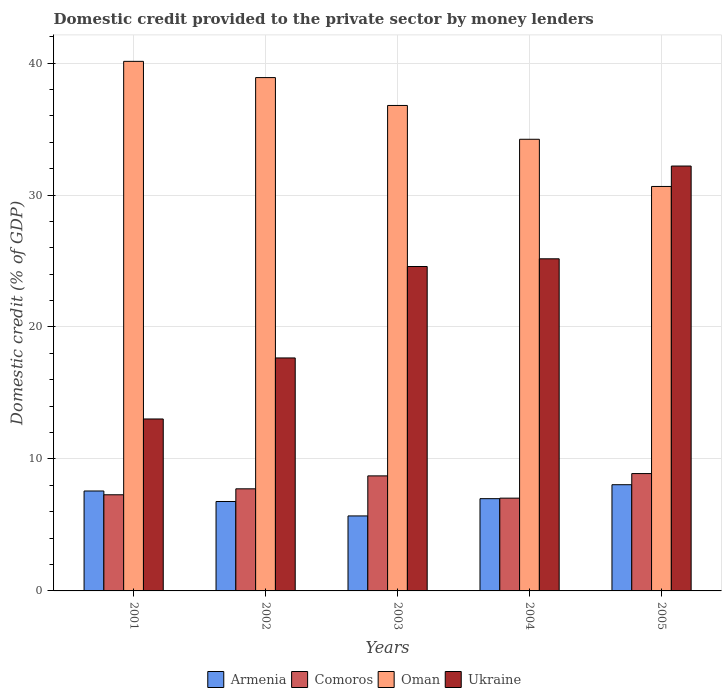How many groups of bars are there?
Your response must be concise. 5. Are the number of bars on each tick of the X-axis equal?
Ensure brevity in your answer.  Yes. In how many cases, is the number of bars for a given year not equal to the number of legend labels?
Offer a terse response. 0. What is the domestic credit provided to the private sector by money lenders in Armenia in 2005?
Provide a succinct answer. 8.05. Across all years, what is the maximum domestic credit provided to the private sector by money lenders in Ukraine?
Make the answer very short. 32.2. Across all years, what is the minimum domestic credit provided to the private sector by money lenders in Armenia?
Ensure brevity in your answer.  5.68. In which year was the domestic credit provided to the private sector by money lenders in Ukraine minimum?
Your response must be concise. 2001. What is the total domestic credit provided to the private sector by money lenders in Armenia in the graph?
Your answer should be compact. 35.07. What is the difference between the domestic credit provided to the private sector by money lenders in Comoros in 2001 and that in 2002?
Provide a short and direct response. -0.45. What is the difference between the domestic credit provided to the private sector by money lenders in Oman in 2001 and the domestic credit provided to the private sector by money lenders in Comoros in 2002?
Provide a short and direct response. 32.39. What is the average domestic credit provided to the private sector by money lenders in Comoros per year?
Give a very brief answer. 7.93. In the year 2001, what is the difference between the domestic credit provided to the private sector by money lenders in Oman and domestic credit provided to the private sector by money lenders in Ukraine?
Offer a very short reply. 27.1. What is the ratio of the domestic credit provided to the private sector by money lenders in Ukraine in 2001 to that in 2002?
Provide a short and direct response. 0.74. Is the domestic credit provided to the private sector by money lenders in Oman in 2001 less than that in 2002?
Your answer should be very brief. No. What is the difference between the highest and the second highest domestic credit provided to the private sector by money lenders in Armenia?
Provide a short and direct response. 0.47. What is the difference between the highest and the lowest domestic credit provided to the private sector by money lenders in Comoros?
Your answer should be very brief. 1.86. Is the sum of the domestic credit provided to the private sector by money lenders in Oman in 2001 and 2002 greater than the maximum domestic credit provided to the private sector by money lenders in Armenia across all years?
Offer a terse response. Yes. Is it the case that in every year, the sum of the domestic credit provided to the private sector by money lenders in Ukraine and domestic credit provided to the private sector by money lenders in Armenia is greater than the sum of domestic credit provided to the private sector by money lenders in Comoros and domestic credit provided to the private sector by money lenders in Oman?
Your answer should be very brief. No. What does the 3rd bar from the left in 2002 represents?
Make the answer very short. Oman. What does the 1st bar from the right in 2003 represents?
Provide a succinct answer. Ukraine. Is it the case that in every year, the sum of the domestic credit provided to the private sector by money lenders in Oman and domestic credit provided to the private sector by money lenders in Armenia is greater than the domestic credit provided to the private sector by money lenders in Ukraine?
Offer a terse response. Yes. How many bars are there?
Offer a terse response. 20. Are all the bars in the graph horizontal?
Give a very brief answer. No. How many years are there in the graph?
Give a very brief answer. 5. Are the values on the major ticks of Y-axis written in scientific E-notation?
Ensure brevity in your answer.  No. Does the graph contain grids?
Your answer should be very brief. Yes. How are the legend labels stacked?
Your answer should be compact. Horizontal. What is the title of the graph?
Provide a succinct answer. Domestic credit provided to the private sector by money lenders. What is the label or title of the Y-axis?
Offer a very short reply. Domestic credit (% of GDP). What is the Domestic credit (% of GDP) in Armenia in 2001?
Provide a succinct answer. 7.57. What is the Domestic credit (% of GDP) in Comoros in 2001?
Your response must be concise. 7.29. What is the Domestic credit (% of GDP) of Oman in 2001?
Make the answer very short. 40.13. What is the Domestic credit (% of GDP) of Ukraine in 2001?
Offer a terse response. 13.03. What is the Domestic credit (% of GDP) of Armenia in 2002?
Offer a terse response. 6.78. What is the Domestic credit (% of GDP) of Comoros in 2002?
Provide a succinct answer. 7.74. What is the Domestic credit (% of GDP) of Oman in 2002?
Provide a succinct answer. 38.9. What is the Domestic credit (% of GDP) of Ukraine in 2002?
Your answer should be very brief. 17.65. What is the Domestic credit (% of GDP) of Armenia in 2003?
Offer a very short reply. 5.68. What is the Domestic credit (% of GDP) of Comoros in 2003?
Offer a terse response. 8.72. What is the Domestic credit (% of GDP) of Oman in 2003?
Keep it short and to the point. 36.79. What is the Domestic credit (% of GDP) of Ukraine in 2003?
Make the answer very short. 24.58. What is the Domestic credit (% of GDP) in Armenia in 2004?
Give a very brief answer. 6.99. What is the Domestic credit (% of GDP) in Comoros in 2004?
Provide a succinct answer. 7.03. What is the Domestic credit (% of GDP) in Oman in 2004?
Provide a succinct answer. 34.23. What is the Domestic credit (% of GDP) of Ukraine in 2004?
Ensure brevity in your answer.  25.17. What is the Domestic credit (% of GDP) in Armenia in 2005?
Provide a short and direct response. 8.05. What is the Domestic credit (% of GDP) of Comoros in 2005?
Provide a short and direct response. 8.89. What is the Domestic credit (% of GDP) in Oman in 2005?
Give a very brief answer. 30.65. What is the Domestic credit (% of GDP) of Ukraine in 2005?
Provide a short and direct response. 32.2. Across all years, what is the maximum Domestic credit (% of GDP) of Armenia?
Offer a very short reply. 8.05. Across all years, what is the maximum Domestic credit (% of GDP) of Comoros?
Your answer should be very brief. 8.89. Across all years, what is the maximum Domestic credit (% of GDP) in Oman?
Ensure brevity in your answer.  40.13. Across all years, what is the maximum Domestic credit (% of GDP) in Ukraine?
Your answer should be very brief. 32.2. Across all years, what is the minimum Domestic credit (% of GDP) in Armenia?
Provide a succinct answer. 5.68. Across all years, what is the minimum Domestic credit (% of GDP) in Comoros?
Make the answer very short. 7.03. Across all years, what is the minimum Domestic credit (% of GDP) of Oman?
Give a very brief answer. 30.65. Across all years, what is the minimum Domestic credit (% of GDP) of Ukraine?
Your answer should be very brief. 13.03. What is the total Domestic credit (% of GDP) of Armenia in the graph?
Offer a very short reply. 35.07. What is the total Domestic credit (% of GDP) in Comoros in the graph?
Offer a terse response. 39.66. What is the total Domestic credit (% of GDP) in Oman in the graph?
Make the answer very short. 180.69. What is the total Domestic credit (% of GDP) in Ukraine in the graph?
Your answer should be compact. 112.63. What is the difference between the Domestic credit (% of GDP) of Armenia in 2001 and that in 2002?
Provide a short and direct response. 0.8. What is the difference between the Domestic credit (% of GDP) in Comoros in 2001 and that in 2002?
Your answer should be compact. -0.45. What is the difference between the Domestic credit (% of GDP) in Oman in 2001 and that in 2002?
Offer a terse response. 1.23. What is the difference between the Domestic credit (% of GDP) in Ukraine in 2001 and that in 2002?
Make the answer very short. -4.63. What is the difference between the Domestic credit (% of GDP) in Armenia in 2001 and that in 2003?
Give a very brief answer. 1.89. What is the difference between the Domestic credit (% of GDP) of Comoros in 2001 and that in 2003?
Ensure brevity in your answer.  -1.43. What is the difference between the Domestic credit (% of GDP) in Oman in 2001 and that in 2003?
Keep it short and to the point. 3.34. What is the difference between the Domestic credit (% of GDP) of Ukraine in 2001 and that in 2003?
Keep it short and to the point. -11.55. What is the difference between the Domestic credit (% of GDP) in Armenia in 2001 and that in 2004?
Keep it short and to the point. 0.58. What is the difference between the Domestic credit (% of GDP) of Comoros in 2001 and that in 2004?
Make the answer very short. 0.26. What is the difference between the Domestic credit (% of GDP) of Oman in 2001 and that in 2004?
Provide a short and direct response. 5.9. What is the difference between the Domestic credit (% of GDP) in Ukraine in 2001 and that in 2004?
Your answer should be very brief. -12.14. What is the difference between the Domestic credit (% of GDP) of Armenia in 2001 and that in 2005?
Offer a very short reply. -0.47. What is the difference between the Domestic credit (% of GDP) of Comoros in 2001 and that in 2005?
Offer a terse response. -1.61. What is the difference between the Domestic credit (% of GDP) in Oman in 2001 and that in 2005?
Your answer should be compact. 9.48. What is the difference between the Domestic credit (% of GDP) in Ukraine in 2001 and that in 2005?
Your answer should be compact. -19.17. What is the difference between the Domestic credit (% of GDP) in Armenia in 2002 and that in 2003?
Keep it short and to the point. 1.09. What is the difference between the Domestic credit (% of GDP) in Comoros in 2002 and that in 2003?
Give a very brief answer. -0.98. What is the difference between the Domestic credit (% of GDP) of Oman in 2002 and that in 2003?
Keep it short and to the point. 2.11. What is the difference between the Domestic credit (% of GDP) in Ukraine in 2002 and that in 2003?
Give a very brief answer. -6.93. What is the difference between the Domestic credit (% of GDP) of Armenia in 2002 and that in 2004?
Offer a terse response. -0.21. What is the difference between the Domestic credit (% of GDP) in Comoros in 2002 and that in 2004?
Offer a very short reply. 0.71. What is the difference between the Domestic credit (% of GDP) of Oman in 2002 and that in 2004?
Offer a very short reply. 4.67. What is the difference between the Domestic credit (% of GDP) in Ukraine in 2002 and that in 2004?
Your answer should be very brief. -7.51. What is the difference between the Domestic credit (% of GDP) of Armenia in 2002 and that in 2005?
Your answer should be very brief. -1.27. What is the difference between the Domestic credit (% of GDP) of Comoros in 2002 and that in 2005?
Give a very brief answer. -1.16. What is the difference between the Domestic credit (% of GDP) in Oman in 2002 and that in 2005?
Offer a very short reply. 8.25. What is the difference between the Domestic credit (% of GDP) in Ukraine in 2002 and that in 2005?
Your answer should be compact. -14.54. What is the difference between the Domestic credit (% of GDP) of Armenia in 2003 and that in 2004?
Give a very brief answer. -1.31. What is the difference between the Domestic credit (% of GDP) of Comoros in 2003 and that in 2004?
Your answer should be compact. 1.69. What is the difference between the Domestic credit (% of GDP) of Oman in 2003 and that in 2004?
Your answer should be compact. 2.56. What is the difference between the Domestic credit (% of GDP) in Ukraine in 2003 and that in 2004?
Your answer should be compact. -0.58. What is the difference between the Domestic credit (% of GDP) in Armenia in 2003 and that in 2005?
Give a very brief answer. -2.37. What is the difference between the Domestic credit (% of GDP) of Comoros in 2003 and that in 2005?
Ensure brevity in your answer.  -0.18. What is the difference between the Domestic credit (% of GDP) in Oman in 2003 and that in 2005?
Offer a terse response. 6.14. What is the difference between the Domestic credit (% of GDP) of Ukraine in 2003 and that in 2005?
Ensure brevity in your answer.  -7.61. What is the difference between the Domestic credit (% of GDP) of Armenia in 2004 and that in 2005?
Ensure brevity in your answer.  -1.06. What is the difference between the Domestic credit (% of GDP) of Comoros in 2004 and that in 2005?
Make the answer very short. -1.86. What is the difference between the Domestic credit (% of GDP) of Oman in 2004 and that in 2005?
Offer a terse response. 3.58. What is the difference between the Domestic credit (% of GDP) in Ukraine in 2004 and that in 2005?
Ensure brevity in your answer.  -7.03. What is the difference between the Domestic credit (% of GDP) of Armenia in 2001 and the Domestic credit (% of GDP) of Comoros in 2002?
Ensure brevity in your answer.  -0.16. What is the difference between the Domestic credit (% of GDP) of Armenia in 2001 and the Domestic credit (% of GDP) of Oman in 2002?
Offer a very short reply. -31.33. What is the difference between the Domestic credit (% of GDP) of Armenia in 2001 and the Domestic credit (% of GDP) of Ukraine in 2002?
Ensure brevity in your answer.  -10.08. What is the difference between the Domestic credit (% of GDP) in Comoros in 2001 and the Domestic credit (% of GDP) in Oman in 2002?
Your answer should be compact. -31.61. What is the difference between the Domestic credit (% of GDP) in Comoros in 2001 and the Domestic credit (% of GDP) in Ukraine in 2002?
Offer a terse response. -10.37. What is the difference between the Domestic credit (% of GDP) in Oman in 2001 and the Domestic credit (% of GDP) in Ukraine in 2002?
Offer a terse response. 22.48. What is the difference between the Domestic credit (% of GDP) of Armenia in 2001 and the Domestic credit (% of GDP) of Comoros in 2003?
Provide a short and direct response. -1.14. What is the difference between the Domestic credit (% of GDP) in Armenia in 2001 and the Domestic credit (% of GDP) in Oman in 2003?
Give a very brief answer. -29.21. What is the difference between the Domestic credit (% of GDP) in Armenia in 2001 and the Domestic credit (% of GDP) in Ukraine in 2003?
Keep it short and to the point. -17.01. What is the difference between the Domestic credit (% of GDP) of Comoros in 2001 and the Domestic credit (% of GDP) of Oman in 2003?
Keep it short and to the point. -29.5. What is the difference between the Domestic credit (% of GDP) in Comoros in 2001 and the Domestic credit (% of GDP) in Ukraine in 2003?
Offer a terse response. -17.3. What is the difference between the Domestic credit (% of GDP) in Oman in 2001 and the Domestic credit (% of GDP) in Ukraine in 2003?
Give a very brief answer. 15.55. What is the difference between the Domestic credit (% of GDP) of Armenia in 2001 and the Domestic credit (% of GDP) of Comoros in 2004?
Make the answer very short. 0.54. What is the difference between the Domestic credit (% of GDP) of Armenia in 2001 and the Domestic credit (% of GDP) of Oman in 2004?
Offer a very short reply. -26.65. What is the difference between the Domestic credit (% of GDP) of Armenia in 2001 and the Domestic credit (% of GDP) of Ukraine in 2004?
Ensure brevity in your answer.  -17.59. What is the difference between the Domestic credit (% of GDP) of Comoros in 2001 and the Domestic credit (% of GDP) of Oman in 2004?
Offer a terse response. -26.94. What is the difference between the Domestic credit (% of GDP) of Comoros in 2001 and the Domestic credit (% of GDP) of Ukraine in 2004?
Make the answer very short. -17.88. What is the difference between the Domestic credit (% of GDP) of Oman in 2001 and the Domestic credit (% of GDP) of Ukraine in 2004?
Offer a terse response. 14.96. What is the difference between the Domestic credit (% of GDP) of Armenia in 2001 and the Domestic credit (% of GDP) of Comoros in 2005?
Give a very brief answer. -1.32. What is the difference between the Domestic credit (% of GDP) in Armenia in 2001 and the Domestic credit (% of GDP) in Oman in 2005?
Offer a terse response. -23.08. What is the difference between the Domestic credit (% of GDP) in Armenia in 2001 and the Domestic credit (% of GDP) in Ukraine in 2005?
Your response must be concise. -24.62. What is the difference between the Domestic credit (% of GDP) of Comoros in 2001 and the Domestic credit (% of GDP) of Oman in 2005?
Provide a short and direct response. -23.36. What is the difference between the Domestic credit (% of GDP) in Comoros in 2001 and the Domestic credit (% of GDP) in Ukraine in 2005?
Provide a short and direct response. -24.91. What is the difference between the Domestic credit (% of GDP) in Oman in 2001 and the Domestic credit (% of GDP) in Ukraine in 2005?
Your answer should be very brief. 7.93. What is the difference between the Domestic credit (% of GDP) in Armenia in 2002 and the Domestic credit (% of GDP) in Comoros in 2003?
Your response must be concise. -1.94. What is the difference between the Domestic credit (% of GDP) in Armenia in 2002 and the Domestic credit (% of GDP) in Oman in 2003?
Offer a terse response. -30.01. What is the difference between the Domestic credit (% of GDP) in Armenia in 2002 and the Domestic credit (% of GDP) in Ukraine in 2003?
Keep it short and to the point. -17.81. What is the difference between the Domestic credit (% of GDP) in Comoros in 2002 and the Domestic credit (% of GDP) in Oman in 2003?
Offer a very short reply. -29.05. What is the difference between the Domestic credit (% of GDP) of Comoros in 2002 and the Domestic credit (% of GDP) of Ukraine in 2003?
Offer a very short reply. -16.85. What is the difference between the Domestic credit (% of GDP) in Oman in 2002 and the Domestic credit (% of GDP) in Ukraine in 2003?
Your response must be concise. 14.32. What is the difference between the Domestic credit (% of GDP) in Armenia in 2002 and the Domestic credit (% of GDP) in Comoros in 2004?
Ensure brevity in your answer.  -0.25. What is the difference between the Domestic credit (% of GDP) in Armenia in 2002 and the Domestic credit (% of GDP) in Oman in 2004?
Ensure brevity in your answer.  -27.45. What is the difference between the Domestic credit (% of GDP) of Armenia in 2002 and the Domestic credit (% of GDP) of Ukraine in 2004?
Your response must be concise. -18.39. What is the difference between the Domestic credit (% of GDP) of Comoros in 2002 and the Domestic credit (% of GDP) of Oman in 2004?
Your response must be concise. -26.49. What is the difference between the Domestic credit (% of GDP) of Comoros in 2002 and the Domestic credit (% of GDP) of Ukraine in 2004?
Provide a succinct answer. -17.43. What is the difference between the Domestic credit (% of GDP) of Oman in 2002 and the Domestic credit (% of GDP) of Ukraine in 2004?
Offer a very short reply. 13.73. What is the difference between the Domestic credit (% of GDP) of Armenia in 2002 and the Domestic credit (% of GDP) of Comoros in 2005?
Offer a very short reply. -2.12. What is the difference between the Domestic credit (% of GDP) in Armenia in 2002 and the Domestic credit (% of GDP) in Oman in 2005?
Your response must be concise. -23.87. What is the difference between the Domestic credit (% of GDP) in Armenia in 2002 and the Domestic credit (% of GDP) in Ukraine in 2005?
Your answer should be compact. -25.42. What is the difference between the Domestic credit (% of GDP) in Comoros in 2002 and the Domestic credit (% of GDP) in Oman in 2005?
Your answer should be compact. -22.91. What is the difference between the Domestic credit (% of GDP) in Comoros in 2002 and the Domestic credit (% of GDP) in Ukraine in 2005?
Ensure brevity in your answer.  -24.46. What is the difference between the Domestic credit (% of GDP) in Oman in 2002 and the Domestic credit (% of GDP) in Ukraine in 2005?
Provide a succinct answer. 6.7. What is the difference between the Domestic credit (% of GDP) of Armenia in 2003 and the Domestic credit (% of GDP) of Comoros in 2004?
Your response must be concise. -1.35. What is the difference between the Domestic credit (% of GDP) in Armenia in 2003 and the Domestic credit (% of GDP) in Oman in 2004?
Keep it short and to the point. -28.54. What is the difference between the Domestic credit (% of GDP) of Armenia in 2003 and the Domestic credit (% of GDP) of Ukraine in 2004?
Make the answer very short. -19.48. What is the difference between the Domestic credit (% of GDP) of Comoros in 2003 and the Domestic credit (% of GDP) of Oman in 2004?
Provide a short and direct response. -25.51. What is the difference between the Domestic credit (% of GDP) in Comoros in 2003 and the Domestic credit (% of GDP) in Ukraine in 2004?
Give a very brief answer. -16.45. What is the difference between the Domestic credit (% of GDP) of Oman in 2003 and the Domestic credit (% of GDP) of Ukraine in 2004?
Keep it short and to the point. 11.62. What is the difference between the Domestic credit (% of GDP) in Armenia in 2003 and the Domestic credit (% of GDP) in Comoros in 2005?
Make the answer very short. -3.21. What is the difference between the Domestic credit (% of GDP) of Armenia in 2003 and the Domestic credit (% of GDP) of Oman in 2005?
Provide a succinct answer. -24.97. What is the difference between the Domestic credit (% of GDP) in Armenia in 2003 and the Domestic credit (% of GDP) in Ukraine in 2005?
Offer a terse response. -26.51. What is the difference between the Domestic credit (% of GDP) in Comoros in 2003 and the Domestic credit (% of GDP) in Oman in 2005?
Your response must be concise. -21.93. What is the difference between the Domestic credit (% of GDP) of Comoros in 2003 and the Domestic credit (% of GDP) of Ukraine in 2005?
Offer a very short reply. -23.48. What is the difference between the Domestic credit (% of GDP) of Oman in 2003 and the Domestic credit (% of GDP) of Ukraine in 2005?
Provide a succinct answer. 4.59. What is the difference between the Domestic credit (% of GDP) in Armenia in 2004 and the Domestic credit (% of GDP) in Comoros in 2005?
Your answer should be very brief. -1.9. What is the difference between the Domestic credit (% of GDP) of Armenia in 2004 and the Domestic credit (% of GDP) of Oman in 2005?
Give a very brief answer. -23.66. What is the difference between the Domestic credit (% of GDP) in Armenia in 2004 and the Domestic credit (% of GDP) in Ukraine in 2005?
Provide a short and direct response. -25.21. What is the difference between the Domestic credit (% of GDP) in Comoros in 2004 and the Domestic credit (% of GDP) in Oman in 2005?
Offer a terse response. -23.62. What is the difference between the Domestic credit (% of GDP) of Comoros in 2004 and the Domestic credit (% of GDP) of Ukraine in 2005?
Your answer should be very brief. -25.17. What is the difference between the Domestic credit (% of GDP) of Oman in 2004 and the Domestic credit (% of GDP) of Ukraine in 2005?
Provide a short and direct response. 2.03. What is the average Domestic credit (% of GDP) in Armenia per year?
Offer a very short reply. 7.01. What is the average Domestic credit (% of GDP) in Comoros per year?
Offer a very short reply. 7.93. What is the average Domestic credit (% of GDP) of Oman per year?
Ensure brevity in your answer.  36.14. What is the average Domestic credit (% of GDP) in Ukraine per year?
Offer a terse response. 22.53. In the year 2001, what is the difference between the Domestic credit (% of GDP) of Armenia and Domestic credit (% of GDP) of Comoros?
Keep it short and to the point. 0.29. In the year 2001, what is the difference between the Domestic credit (% of GDP) of Armenia and Domestic credit (% of GDP) of Oman?
Provide a short and direct response. -32.56. In the year 2001, what is the difference between the Domestic credit (% of GDP) in Armenia and Domestic credit (% of GDP) in Ukraine?
Give a very brief answer. -5.46. In the year 2001, what is the difference between the Domestic credit (% of GDP) of Comoros and Domestic credit (% of GDP) of Oman?
Offer a very short reply. -32.84. In the year 2001, what is the difference between the Domestic credit (% of GDP) in Comoros and Domestic credit (% of GDP) in Ukraine?
Offer a terse response. -5.74. In the year 2001, what is the difference between the Domestic credit (% of GDP) of Oman and Domestic credit (% of GDP) of Ukraine?
Ensure brevity in your answer.  27.1. In the year 2002, what is the difference between the Domestic credit (% of GDP) in Armenia and Domestic credit (% of GDP) in Comoros?
Provide a short and direct response. -0.96. In the year 2002, what is the difference between the Domestic credit (% of GDP) in Armenia and Domestic credit (% of GDP) in Oman?
Give a very brief answer. -32.12. In the year 2002, what is the difference between the Domestic credit (% of GDP) in Armenia and Domestic credit (% of GDP) in Ukraine?
Make the answer very short. -10.88. In the year 2002, what is the difference between the Domestic credit (% of GDP) in Comoros and Domestic credit (% of GDP) in Oman?
Your answer should be very brief. -31.16. In the year 2002, what is the difference between the Domestic credit (% of GDP) of Comoros and Domestic credit (% of GDP) of Ukraine?
Ensure brevity in your answer.  -9.92. In the year 2002, what is the difference between the Domestic credit (% of GDP) in Oman and Domestic credit (% of GDP) in Ukraine?
Your response must be concise. 21.24. In the year 2003, what is the difference between the Domestic credit (% of GDP) in Armenia and Domestic credit (% of GDP) in Comoros?
Ensure brevity in your answer.  -3.04. In the year 2003, what is the difference between the Domestic credit (% of GDP) of Armenia and Domestic credit (% of GDP) of Oman?
Provide a succinct answer. -31.11. In the year 2003, what is the difference between the Domestic credit (% of GDP) in Armenia and Domestic credit (% of GDP) in Ukraine?
Offer a very short reply. -18.9. In the year 2003, what is the difference between the Domestic credit (% of GDP) in Comoros and Domestic credit (% of GDP) in Oman?
Your answer should be compact. -28.07. In the year 2003, what is the difference between the Domestic credit (% of GDP) of Comoros and Domestic credit (% of GDP) of Ukraine?
Make the answer very short. -15.87. In the year 2003, what is the difference between the Domestic credit (% of GDP) in Oman and Domestic credit (% of GDP) in Ukraine?
Provide a succinct answer. 12.2. In the year 2004, what is the difference between the Domestic credit (% of GDP) of Armenia and Domestic credit (% of GDP) of Comoros?
Make the answer very short. -0.04. In the year 2004, what is the difference between the Domestic credit (% of GDP) in Armenia and Domestic credit (% of GDP) in Oman?
Your response must be concise. -27.23. In the year 2004, what is the difference between the Domestic credit (% of GDP) in Armenia and Domestic credit (% of GDP) in Ukraine?
Make the answer very short. -18.18. In the year 2004, what is the difference between the Domestic credit (% of GDP) of Comoros and Domestic credit (% of GDP) of Oman?
Keep it short and to the point. -27.19. In the year 2004, what is the difference between the Domestic credit (% of GDP) of Comoros and Domestic credit (% of GDP) of Ukraine?
Your response must be concise. -18.14. In the year 2004, what is the difference between the Domestic credit (% of GDP) of Oman and Domestic credit (% of GDP) of Ukraine?
Your answer should be very brief. 9.06. In the year 2005, what is the difference between the Domestic credit (% of GDP) in Armenia and Domestic credit (% of GDP) in Comoros?
Give a very brief answer. -0.84. In the year 2005, what is the difference between the Domestic credit (% of GDP) in Armenia and Domestic credit (% of GDP) in Oman?
Provide a short and direct response. -22.6. In the year 2005, what is the difference between the Domestic credit (% of GDP) of Armenia and Domestic credit (% of GDP) of Ukraine?
Ensure brevity in your answer.  -24.15. In the year 2005, what is the difference between the Domestic credit (% of GDP) in Comoros and Domestic credit (% of GDP) in Oman?
Offer a terse response. -21.76. In the year 2005, what is the difference between the Domestic credit (% of GDP) of Comoros and Domestic credit (% of GDP) of Ukraine?
Provide a succinct answer. -23.3. In the year 2005, what is the difference between the Domestic credit (% of GDP) in Oman and Domestic credit (% of GDP) in Ukraine?
Ensure brevity in your answer.  -1.55. What is the ratio of the Domestic credit (% of GDP) of Armenia in 2001 to that in 2002?
Your response must be concise. 1.12. What is the ratio of the Domestic credit (% of GDP) of Comoros in 2001 to that in 2002?
Provide a short and direct response. 0.94. What is the ratio of the Domestic credit (% of GDP) of Oman in 2001 to that in 2002?
Offer a terse response. 1.03. What is the ratio of the Domestic credit (% of GDP) of Ukraine in 2001 to that in 2002?
Give a very brief answer. 0.74. What is the ratio of the Domestic credit (% of GDP) of Armenia in 2001 to that in 2003?
Your answer should be compact. 1.33. What is the ratio of the Domestic credit (% of GDP) of Comoros in 2001 to that in 2003?
Give a very brief answer. 0.84. What is the ratio of the Domestic credit (% of GDP) of Oman in 2001 to that in 2003?
Make the answer very short. 1.09. What is the ratio of the Domestic credit (% of GDP) of Ukraine in 2001 to that in 2003?
Make the answer very short. 0.53. What is the ratio of the Domestic credit (% of GDP) of Comoros in 2001 to that in 2004?
Keep it short and to the point. 1.04. What is the ratio of the Domestic credit (% of GDP) in Oman in 2001 to that in 2004?
Provide a short and direct response. 1.17. What is the ratio of the Domestic credit (% of GDP) of Ukraine in 2001 to that in 2004?
Give a very brief answer. 0.52. What is the ratio of the Domestic credit (% of GDP) of Armenia in 2001 to that in 2005?
Provide a short and direct response. 0.94. What is the ratio of the Domestic credit (% of GDP) in Comoros in 2001 to that in 2005?
Your answer should be compact. 0.82. What is the ratio of the Domestic credit (% of GDP) in Oman in 2001 to that in 2005?
Provide a succinct answer. 1.31. What is the ratio of the Domestic credit (% of GDP) in Ukraine in 2001 to that in 2005?
Keep it short and to the point. 0.4. What is the ratio of the Domestic credit (% of GDP) in Armenia in 2002 to that in 2003?
Provide a short and direct response. 1.19. What is the ratio of the Domestic credit (% of GDP) in Comoros in 2002 to that in 2003?
Make the answer very short. 0.89. What is the ratio of the Domestic credit (% of GDP) in Oman in 2002 to that in 2003?
Give a very brief answer. 1.06. What is the ratio of the Domestic credit (% of GDP) of Ukraine in 2002 to that in 2003?
Your answer should be compact. 0.72. What is the ratio of the Domestic credit (% of GDP) of Armenia in 2002 to that in 2004?
Keep it short and to the point. 0.97. What is the ratio of the Domestic credit (% of GDP) in Comoros in 2002 to that in 2004?
Your answer should be very brief. 1.1. What is the ratio of the Domestic credit (% of GDP) of Oman in 2002 to that in 2004?
Offer a very short reply. 1.14. What is the ratio of the Domestic credit (% of GDP) of Ukraine in 2002 to that in 2004?
Make the answer very short. 0.7. What is the ratio of the Domestic credit (% of GDP) in Armenia in 2002 to that in 2005?
Your answer should be compact. 0.84. What is the ratio of the Domestic credit (% of GDP) in Comoros in 2002 to that in 2005?
Your answer should be very brief. 0.87. What is the ratio of the Domestic credit (% of GDP) of Oman in 2002 to that in 2005?
Make the answer very short. 1.27. What is the ratio of the Domestic credit (% of GDP) in Ukraine in 2002 to that in 2005?
Offer a very short reply. 0.55. What is the ratio of the Domestic credit (% of GDP) in Armenia in 2003 to that in 2004?
Offer a very short reply. 0.81. What is the ratio of the Domestic credit (% of GDP) in Comoros in 2003 to that in 2004?
Give a very brief answer. 1.24. What is the ratio of the Domestic credit (% of GDP) in Oman in 2003 to that in 2004?
Offer a terse response. 1.07. What is the ratio of the Domestic credit (% of GDP) of Ukraine in 2003 to that in 2004?
Your answer should be compact. 0.98. What is the ratio of the Domestic credit (% of GDP) of Armenia in 2003 to that in 2005?
Provide a short and direct response. 0.71. What is the ratio of the Domestic credit (% of GDP) in Comoros in 2003 to that in 2005?
Offer a terse response. 0.98. What is the ratio of the Domestic credit (% of GDP) in Oman in 2003 to that in 2005?
Your response must be concise. 1.2. What is the ratio of the Domestic credit (% of GDP) of Ukraine in 2003 to that in 2005?
Ensure brevity in your answer.  0.76. What is the ratio of the Domestic credit (% of GDP) in Armenia in 2004 to that in 2005?
Ensure brevity in your answer.  0.87. What is the ratio of the Domestic credit (% of GDP) in Comoros in 2004 to that in 2005?
Ensure brevity in your answer.  0.79. What is the ratio of the Domestic credit (% of GDP) of Oman in 2004 to that in 2005?
Keep it short and to the point. 1.12. What is the ratio of the Domestic credit (% of GDP) of Ukraine in 2004 to that in 2005?
Your answer should be compact. 0.78. What is the difference between the highest and the second highest Domestic credit (% of GDP) of Armenia?
Keep it short and to the point. 0.47. What is the difference between the highest and the second highest Domestic credit (% of GDP) of Comoros?
Offer a very short reply. 0.18. What is the difference between the highest and the second highest Domestic credit (% of GDP) in Oman?
Your answer should be very brief. 1.23. What is the difference between the highest and the second highest Domestic credit (% of GDP) of Ukraine?
Ensure brevity in your answer.  7.03. What is the difference between the highest and the lowest Domestic credit (% of GDP) of Armenia?
Give a very brief answer. 2.37. What is the difference between the highest and the lowest Domestic credit (% of GDP) of Comoros?
Offer a very short reply. 1.86. What is the difference between the highest and the lowest Domestic credit (% of GDP) of Oman?
Give a very brief answer. 9.48. What is the difference between the highest and the lowest Domestic credit (% of GDP) in Ukraine?
Your answer should be very brief. 19.17. 